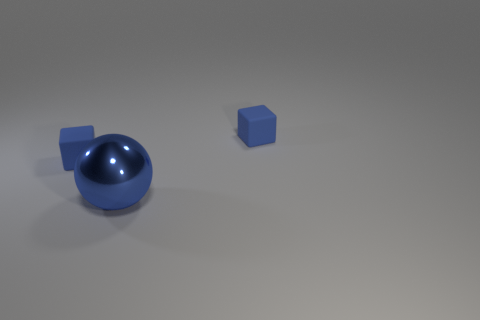Are there any shiny objects in front of the blue sphere?
Your answer should be compact. No. Are there any rubber blocks that are left of the blue cube that is right of the sphere?
Provide a succinct answer. Yes. Is there anything else that has the same size as the blue shiny sphere?
Ensure brevity in your answer.  No. The big blue thing is what shape?
Your answer should be very brief. Sphere. There is a small object to the left of the large sphere; what is it made of?
Provide a short and direct response. Rubber. There is a blue shiny object that is in front of the small cube that is behind the small blue cube that is on the left side of the blue ball; how big is it?
Offer a terse response. Large. Do the blue thing right of the blue ball and the small block that is on the left side of the big blue metal thing have the same material?
Provide a succinct answer. Yes. What number of other things are the same color as the large thing?
Your answer should be very brief. 2. How many objects are blue matte things that are on the right side of the sphere or small blocks that are on the left side of the blue sphere?
Give a very brief answer. 2. There is a cube left of the thing on the right side of the large blue metallic sphere; how big is it?
Make the answer very short. Small. 